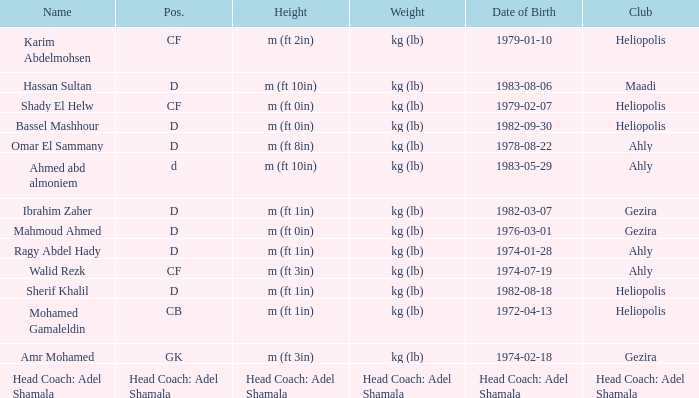What is Name, when Weight is "kg (lb)", when Club is "Gezira", and when Date of Birth is "1974-02-18"? Amr Mohamed. 